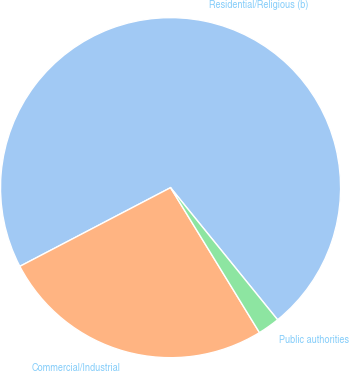Convert chart. <chart><loc_0><loc_0><loc_500><loc_500><pie_chart><fcel>Residential/Religious (b)<fcel>Commercial/Industrial<fcel>Public authorities<nl><fcel>71.82%<fcel>26.1%<fcel>2.08%<nl></chart> 